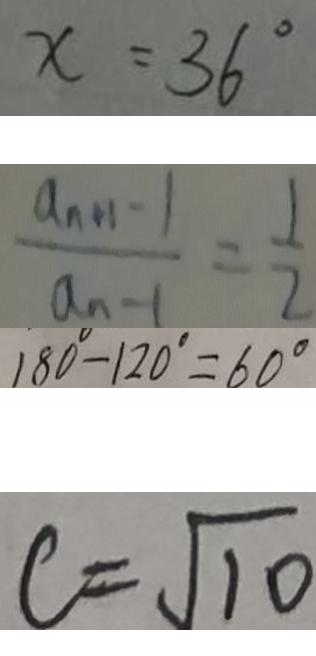<formula> <loc_0><loc_0><loc_500><loc_500>x = 3 6 ^ { \circ } 
 \frac { a _ { n + 1 } - 1 } { a _ { n - 1 } } = \frac { 1 } { 2 } 
 1 8 0 ^ { \circ } - 1 2 0 ^ { \circ } = 6 0 ^ { \circ } 
 c = \sqrt { 1 0 }</formula> 